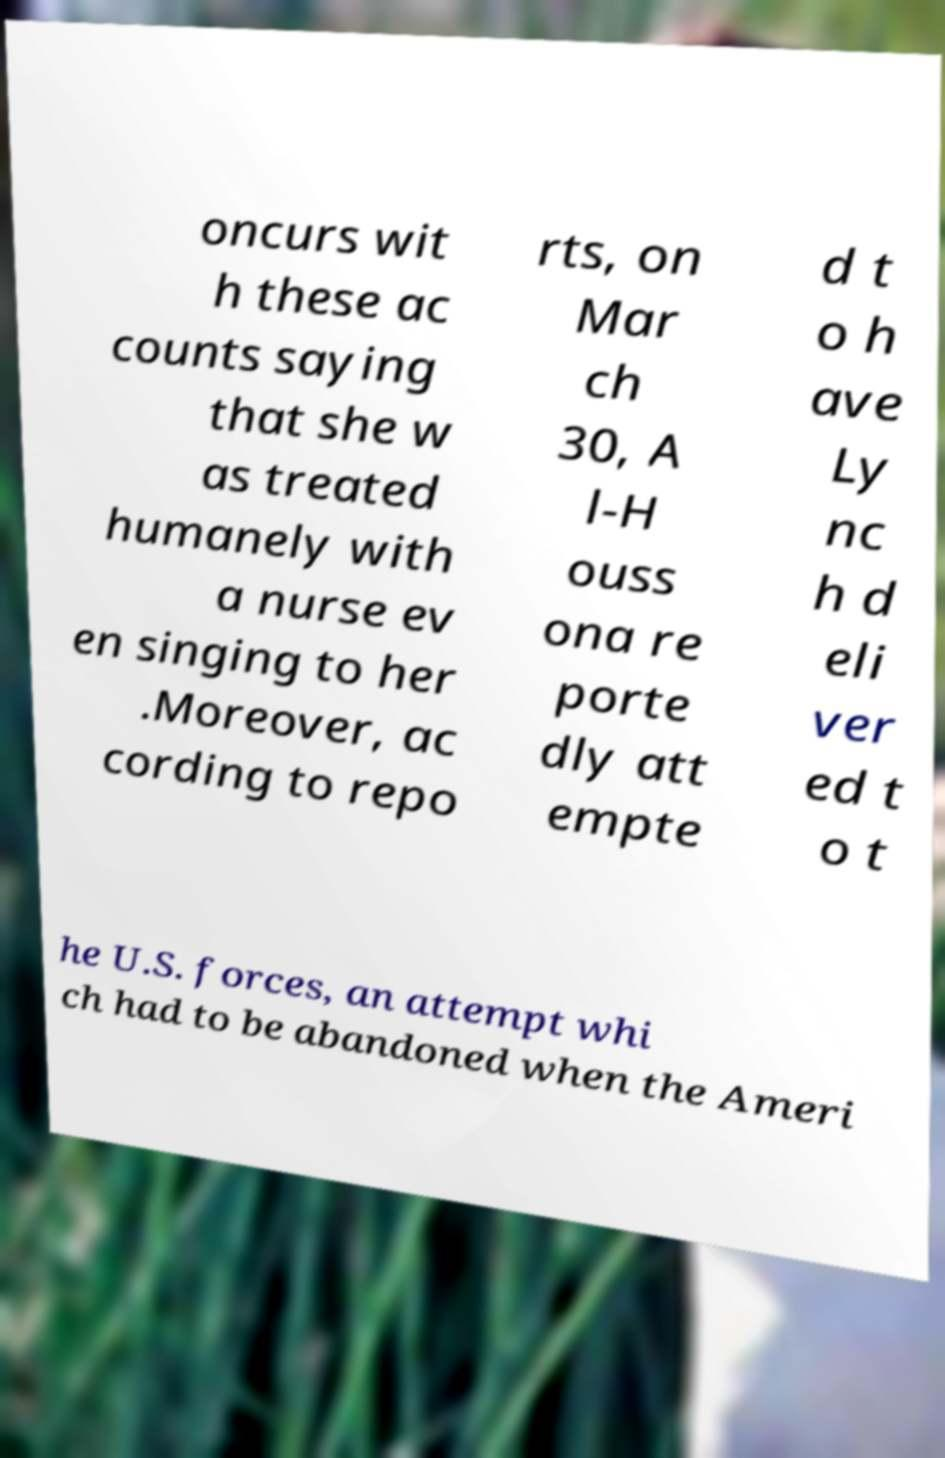For documentation purposes, I need the text within this image transcribed. Could you provide that? oncurs wit h these ac counts saying that she w as treated humanely with a nurse ev en singing to her .Moreover, ac cording to repo rts, on Mar ch 30, A l-H ouss ona re porte dly att empte d t o h ave Ly nc h d eli ver ed t o t he U.S. forces, an attempt whi ch had to be abandoned when the Ameri 